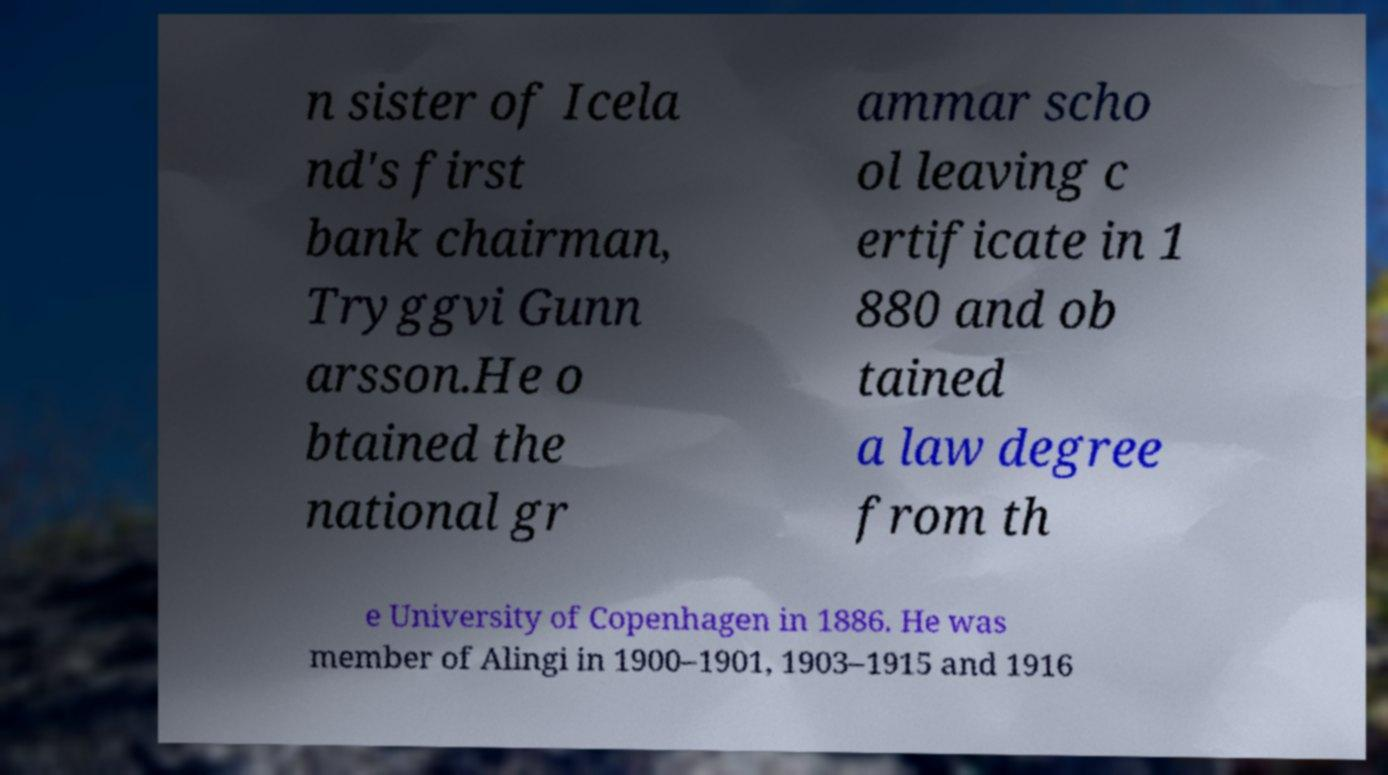Could you assist in decoding the text presented in this image and type it out clearly? n sister of Icela nd's first bank chairman, Tryggvi Gunn arsson.He o btained the national gr ammar scho ol leaving c ertificate in 1 880 and ob tained a law degree from th e University of Copenhagen in 1886. He was member of Alingi in 1900–1901, 1903–1915 and 1916 